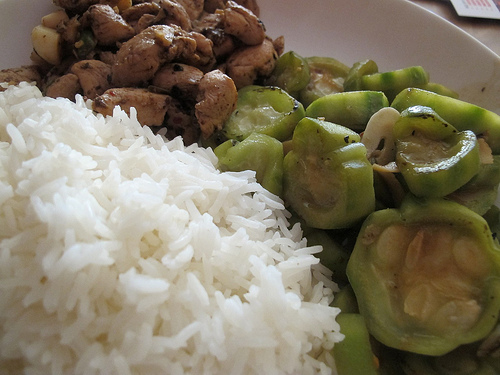<image>
Can you confirm if the rice is on the table? Yes. Looking at the image, I can see the rice is positioned on top of the table, with the table providing support. Is there a rice in front of the plate? No. The rice is not in front of the plate. The spatial positioning shows a different relationship between these objects. 